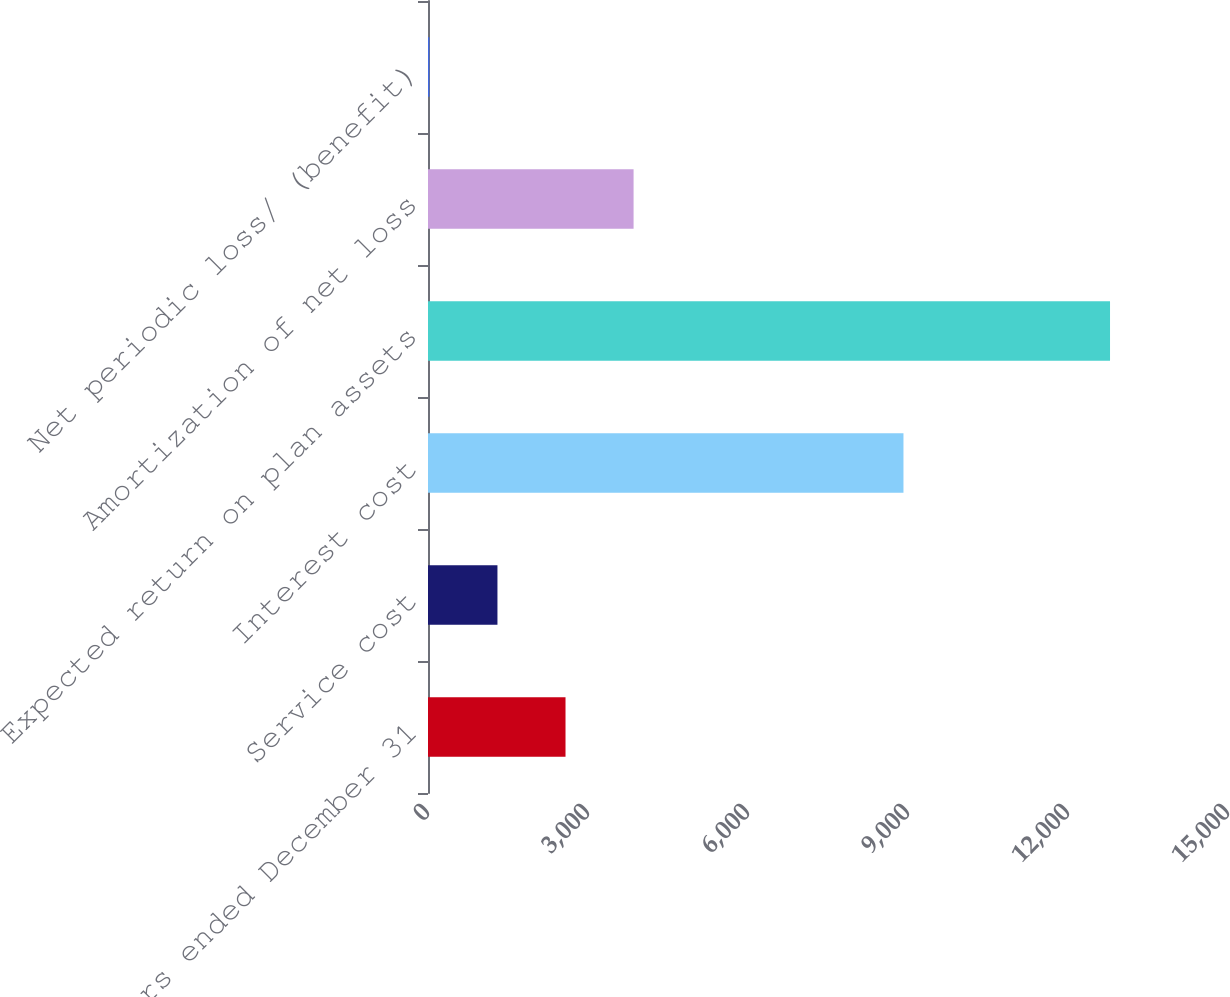<chart> <loc_0><loc_0><loc_500><loc_500><bar_chart><fcel>Years ended December 31<fcel>Service cost<fcel>Interest cost<fcel>Expected return on plan assets<fcel>Amortization of net loss<fcel>Net periodic loss/ (benefit)<nl><fcel>2578.4<fcel>1302.2<fcel>8915<fcel>12788<fcel>3854.6<fcel>26<nl></chart> 